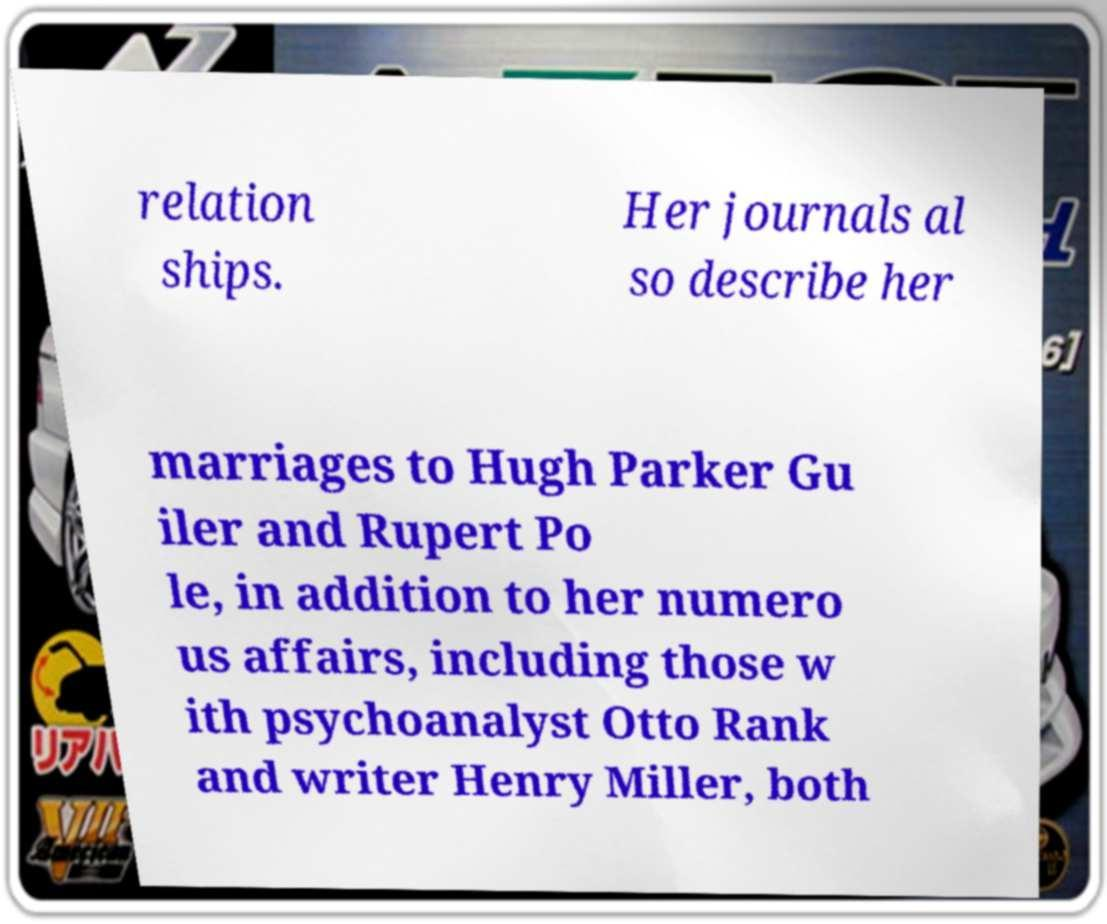Could you extract and type out the text from this image? relation ships. Her journals al so describe her marriages to Hugh Parker Gu iler and Rupert Po le, in addition to her numero us affairs, including those w ith psychoanalyst Otto Rank and writer Henry Miller, both 